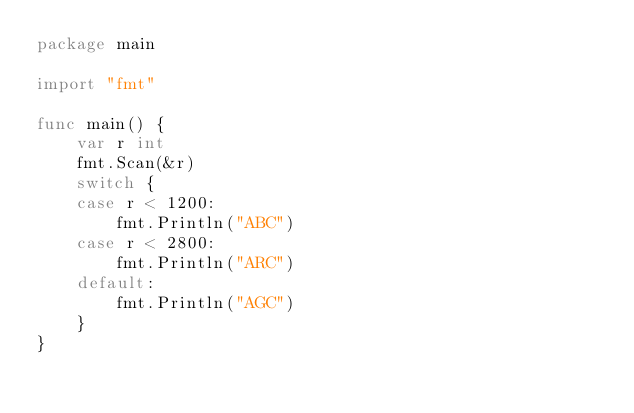<code> <loc_0><loc_0><loc_500><loc_500><_Go_>package main

import "fmt"

func main() {
	var r int
	fmt.Scan(&r)
	switch {
	case r < 1200:
		fmt.Println("ABC")
	case r < 2800:
		fmt.Println("ARC")
	default:
		fmt.Println("AGC")
	}
}
</code> 